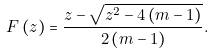Convert formula to latex. <formula><loc_0><loc_0><loc_500><loc_500>F \left ( z \right ) = \frac { z - \sqrt { z ^ { 2 } - 4 \left ( m - 1 \right ) } } { 2 \left ( m - 1 \right ) } .</formula> 